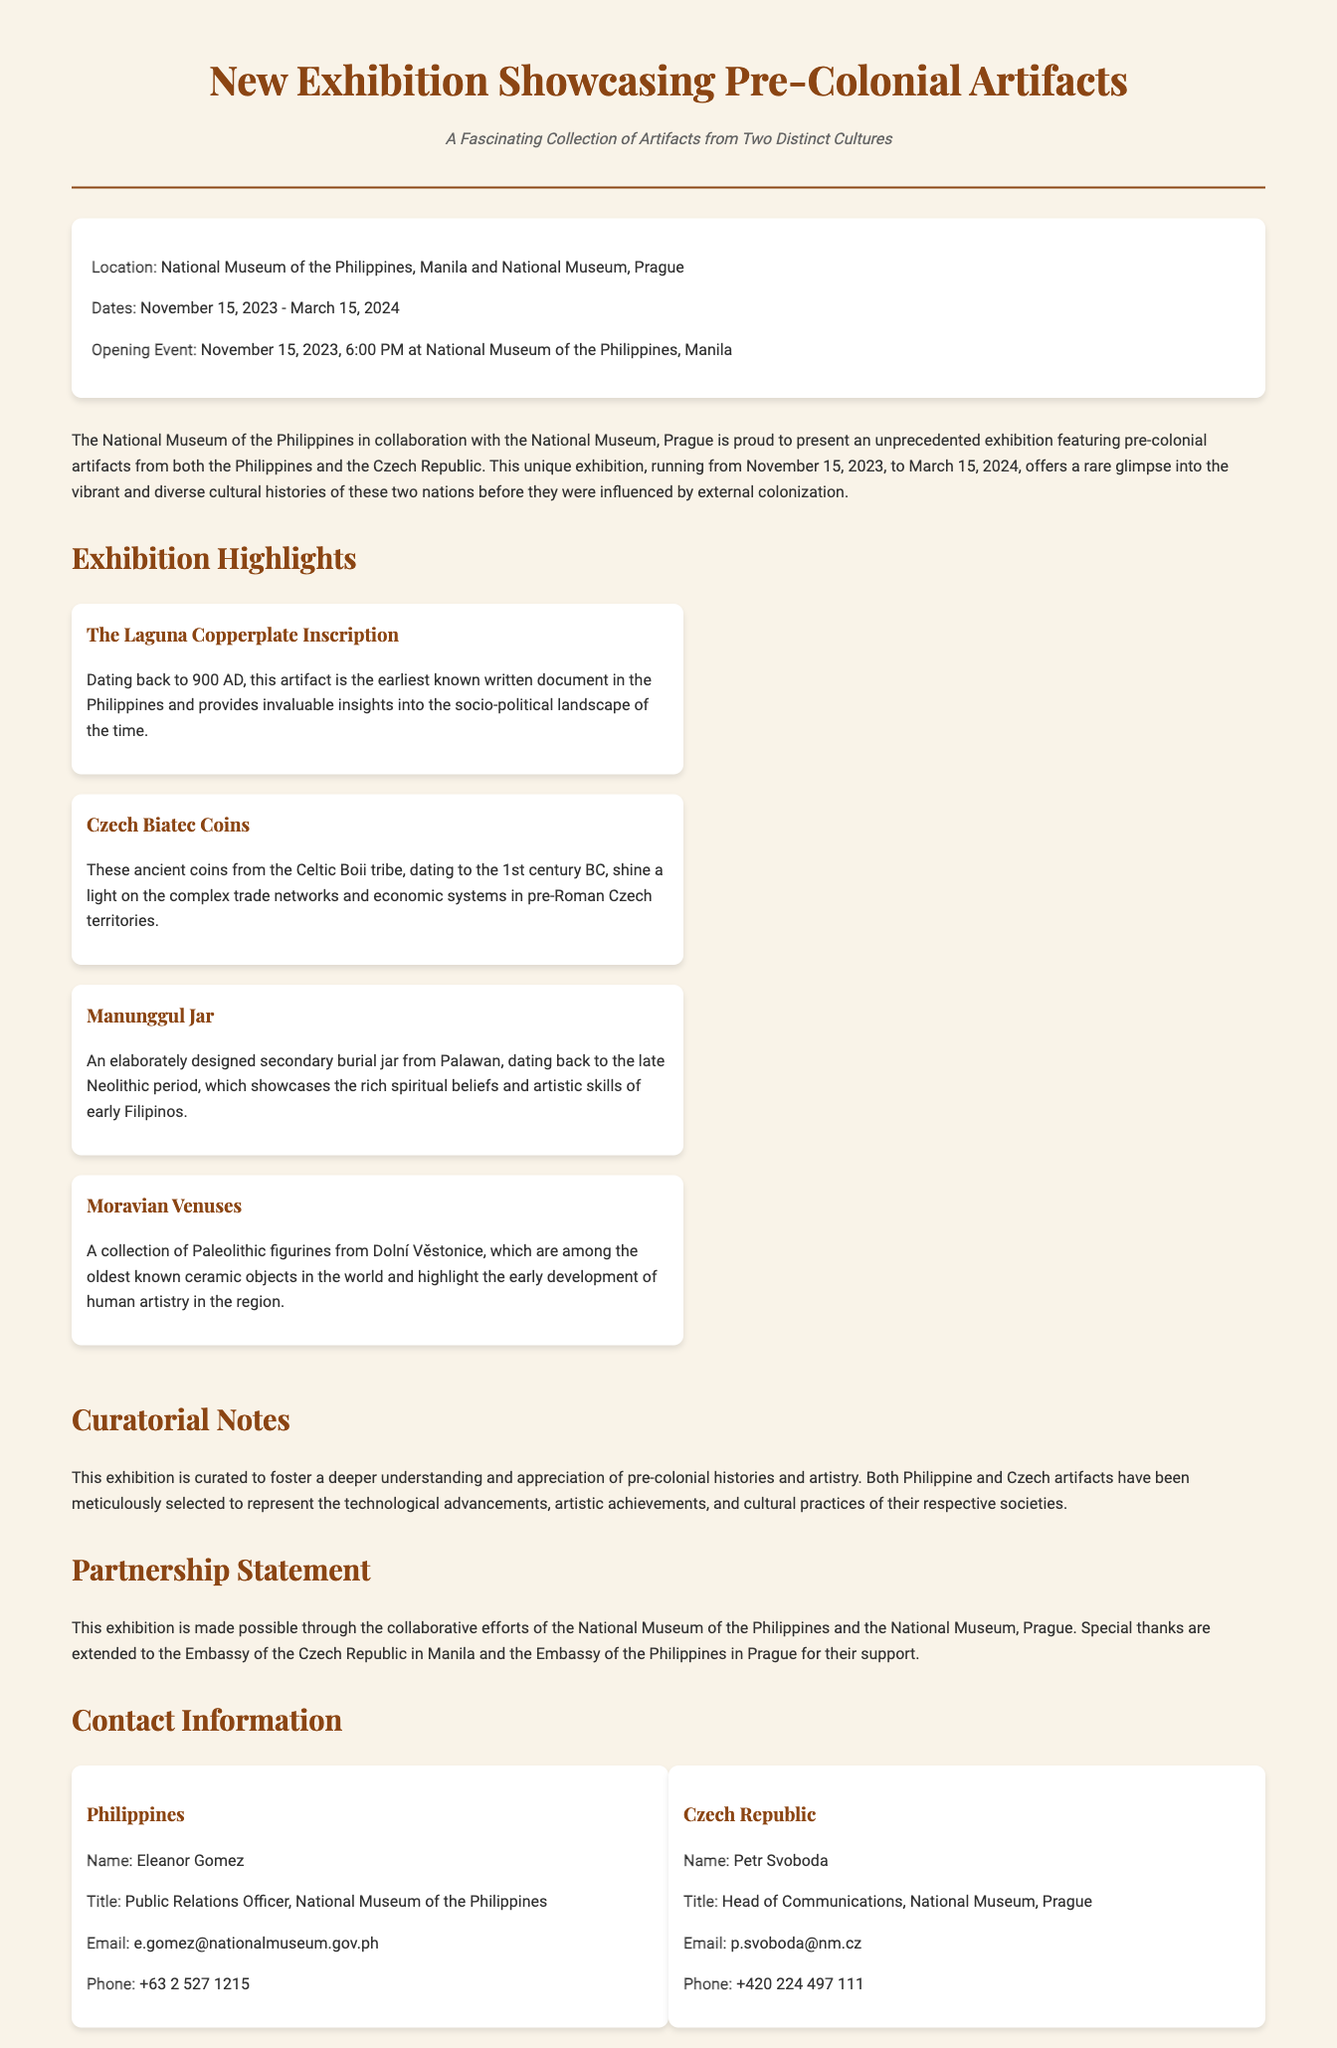What are the exhibition dates? The exhibition dates are clearly stated in the document as November 15, 2023 to March 15, 2024.
Answer: November 15, 2023 - March 15, 2024 Where is the opening event taking place? The location of the opening event is highlighted in the document, specifically at the National Museum of the Philippines, Manila.
Answer: National Museum of the Philippines, Manila What is the title of the earliest known written document in the Philippines? The title of this artifact is mentioned as the Laguna Copperplate Inscription, which is noted in the exhibition highlights.
Answer: Laguna Copperplate Inscription Who is the Public Relations Officer for the National Museum of the Philippines? This information is found in the contact section, where Eleanor Gomez is listed as the Public Relations Officer.
Answer: Eleanor Gomez What cultural elements do the pre-colonial artifacts on display represent? The document states that the artifacts are meant to represent the technological advancements, artistic achievements, and cultural practices of their respective societies.
Answer: Technological advancements, artistic achievements, and cultural practices Which ancient coins are included in the exhibition? The document lists Czech Biatec Coins as part of the exhibition highlights, mentioning their historical significance.
Answer: Czech Biatec Coins What artifact showcases the rich spiritual beliefs of early Filipinos? The document identifies the Manunggul Jar as the artifact that showcases the rich spiritual beliefs of early Filipinos.
Answer: Manunggul Jar What organizations collaborated to create this exhibition? The document states that the National Museum of the Philippines and the National Museum, Prague collaborated for this exhibition.
Answer: National Museum of the Philippines and National Museum, Prague 